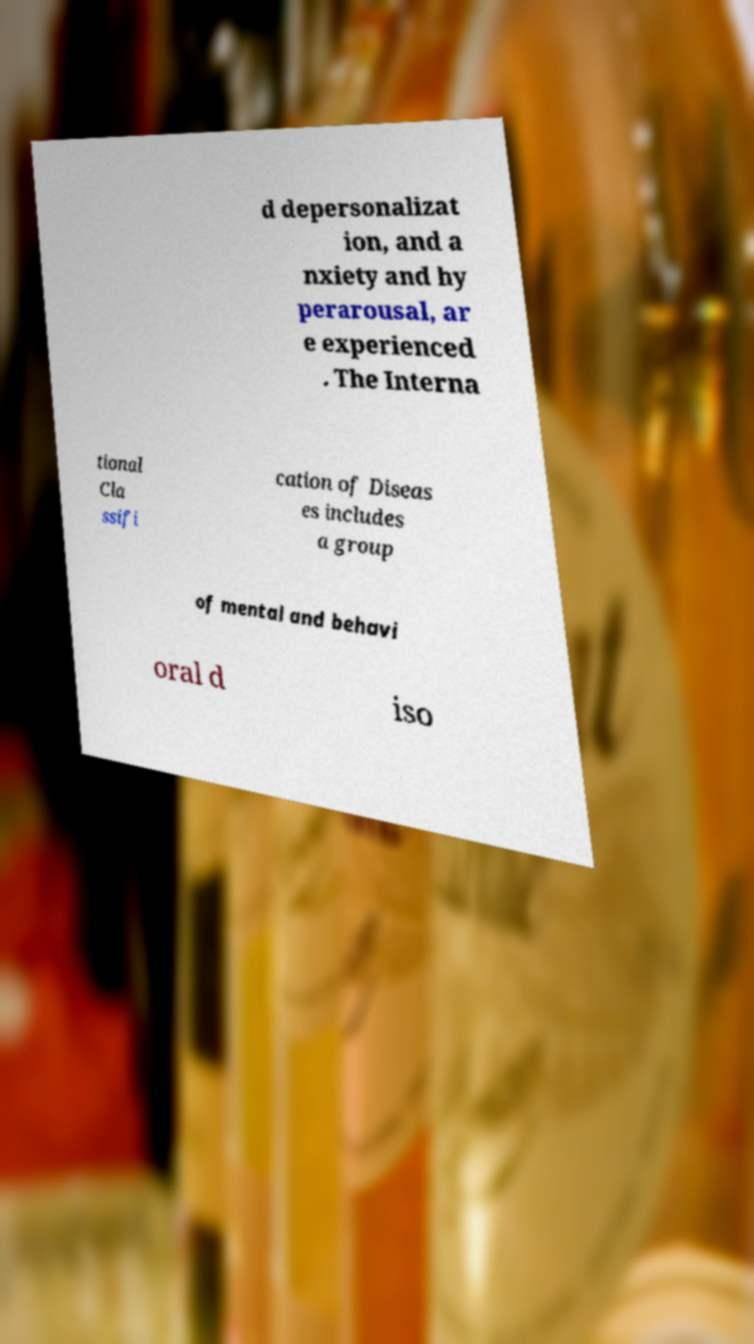Could you assist in decoding the text presented in this image and type it out clearly? d depersonalizat ion, and a nxiety and hy perarousal, ar e experienced . The Interna tional Cla ssifi cation of Diseas es includes a group of mental and behavi oral d iso 